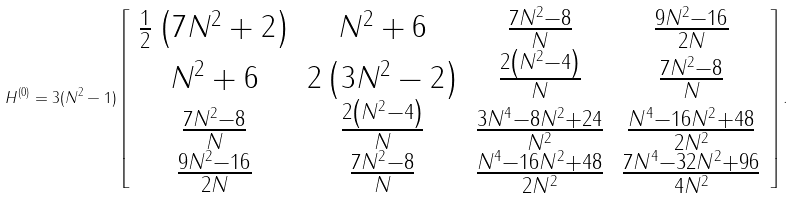<formula> <loc_0><loc_0><loc_500><loc_500>H ^ { ( 0 ) } = 3 ( N ^ { 2 } - 1 ) \left [ \begin{array} { c c c c } \frac { 1 } { 2 } \left ( 7 N ^ { 2 } + 2 \right ) & N ^ { 2 } + 6 & \frac { 7 N ^ { 2 } - 8 } { N } & \frac { 9 N ^ { 2 } - 1 6 } { 2 N } \\ N ^ { 2 } + 6 & 2 \left ( 3 N ^ { 2 } - 2 \right ) & \frac { 2 \left ( N ^ { 2 } - 4 \right ) } { N } & \frac { 7 N ^ { 2 } - 8 } { N } \\ \frac { 7 N ^ { 2 } - 8 } { N } & \frac { 2 \left ( N ^ { 2 } - 4 \right ) } { N } & \frac { 3 N ^ { 4 } - 8 N ^ { 2 } + 2 4 } { N ^ { 2 } } & \frac { N ^ { 4 } - 1 6 N ^ { 2 } + 4 8 } { 2 N ^ { 2 } } \\ \frac { 9 N ^ { 2 } - 1 6 } { 2 N } & \frac { 7 N ^ { 2 } - 8 } { N } & \frac { N ^ { 4 } - 1 6 N ^ { 2 } + 4 8 } { 2 N ^ { 2 } } & \frac { 7 N ^ { 4 } - 3 2 N ^ { 2 } + 9 6 } { 4 N ^ { 2 } } \\ \end{array} \right ] .</formula> 